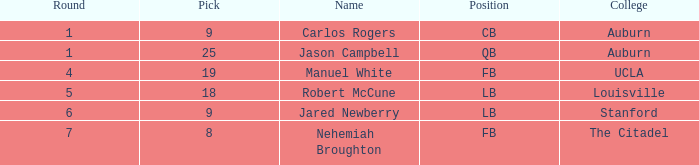Which university had a total selection of 9? Auburn. 